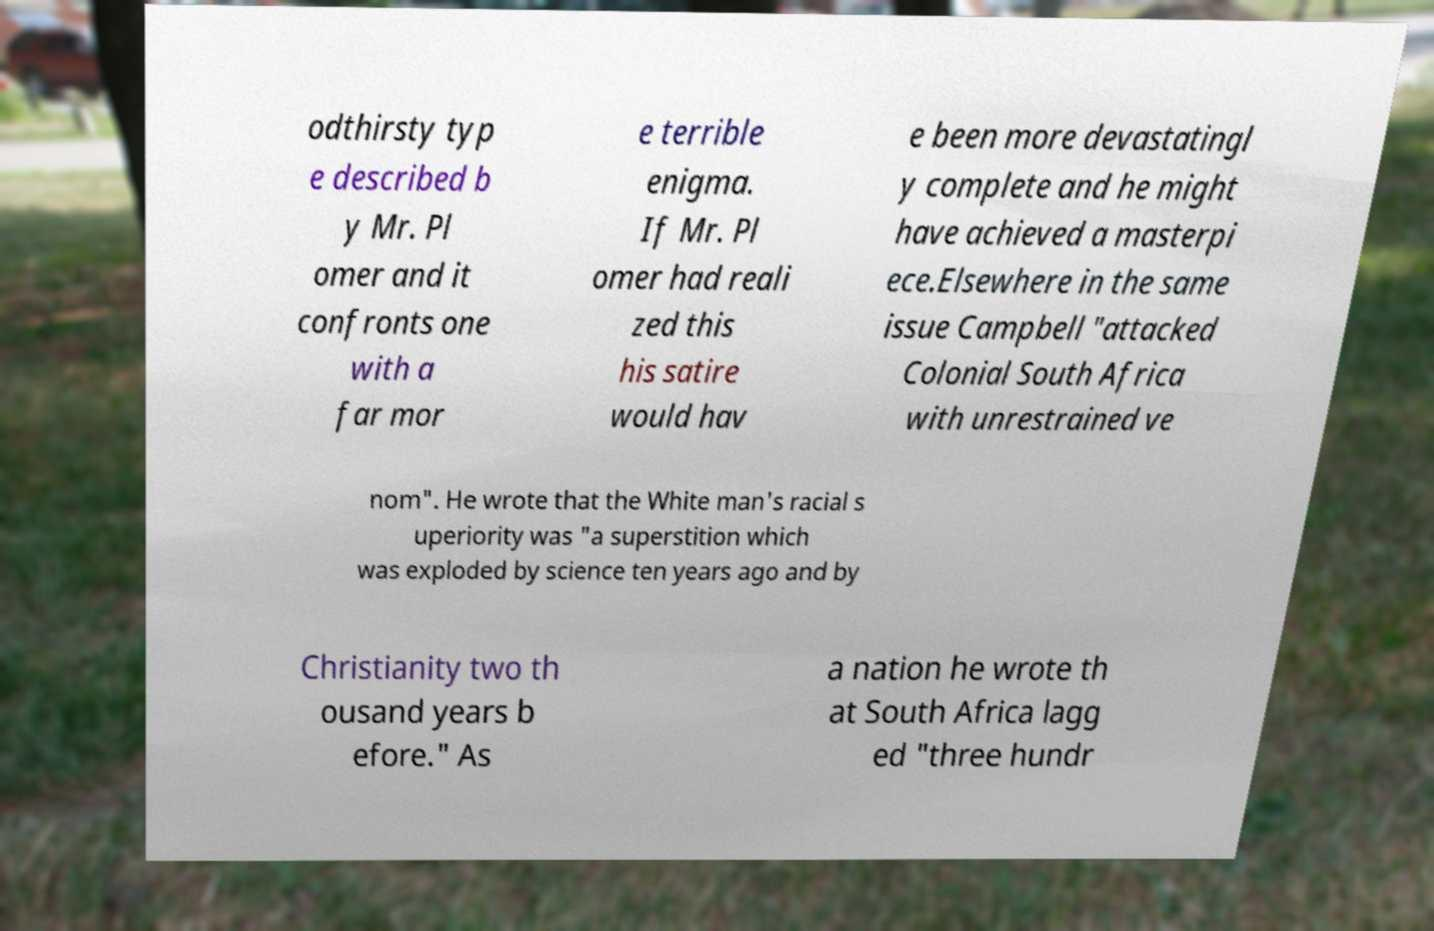Could you assist in decoding the text presented in this image and type it out clearly? odthirsty typ e described b y Mr. Pl omer and it confronts one with a far mor e terrible enigma. If Mr. Pl omer had reali zed this his satire would hav e been more devastatingl y complete and he might have achieved a masterpi ece.Elsewhere in the same issue Campbell "attacked Colonial South Africa with unrestrained ve nom". He wrote that the White man's racial s uperiority was "a superstition which was exploded by science ten years ago and by Christianity two th ousand years b efore." As a nation he wrote th at South Africa lagg ed "three hundr 